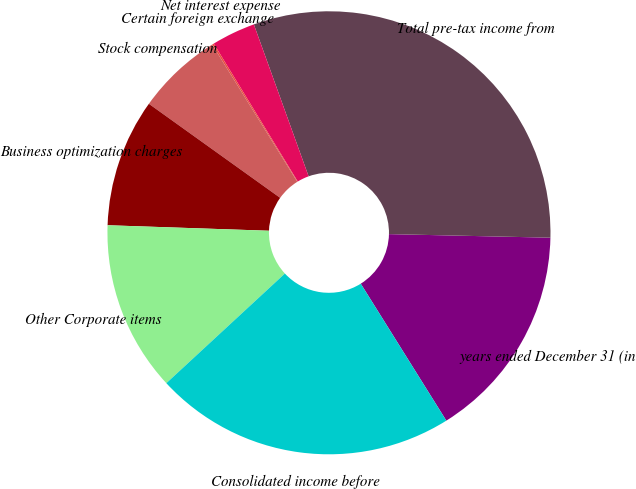Convert chart. <chart><loc_0><loc_0><loc_500><loc_500><pie_chart><fcel>years ended December 31 (in<fcel>Total pre-tax income from<fcel>Net interest expense<fcel>Certain foreign exchange<fcel>Stock compensation<fcel>Business optimization charges<fcel>Other Corporate items<fcel>Consolidated income before<nl><fcel>15.76%<fcel>30.86%<fcel>3.2%<fcel>0.13%<fcel>6.27%<fcel>9.35%<fcel>12.42%<fcel>22.01%<nl></chart> 